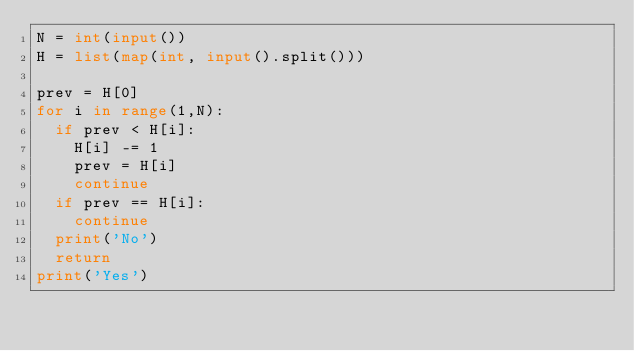Convert code to text. <code><loc_0><loc_0><loc_500><loc_500><_Python_>N = int(input())
H = list(map(int, input().split()))

prev = H[0]
for i in range(1,N):
  if prev < H[i]:
    H[i] -= 1
    prev = H[i]
    continue
  if prev == H[i]:
    continue
  print('No')
  return
print('Yes')
</code> 